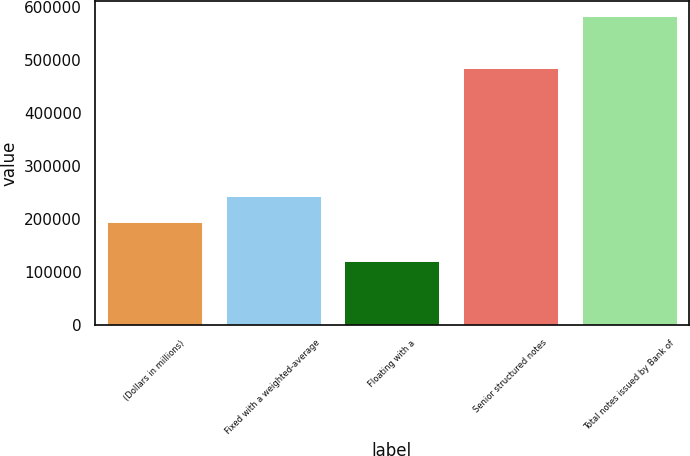Convert chart. <chart><loc_0><loc_0><loc_500><loc_500><bar_chart><fcel>(Dollars in millions)<fcel>Fixed with a weighted-average<fcel>Floating with a<fcel>Senior structured notes<fcel>Total notes issued by Bank of<nl><fcel>194511<fcel>243139<fcel>121570<fcel>486277<fcel>583532<nl></chart> 